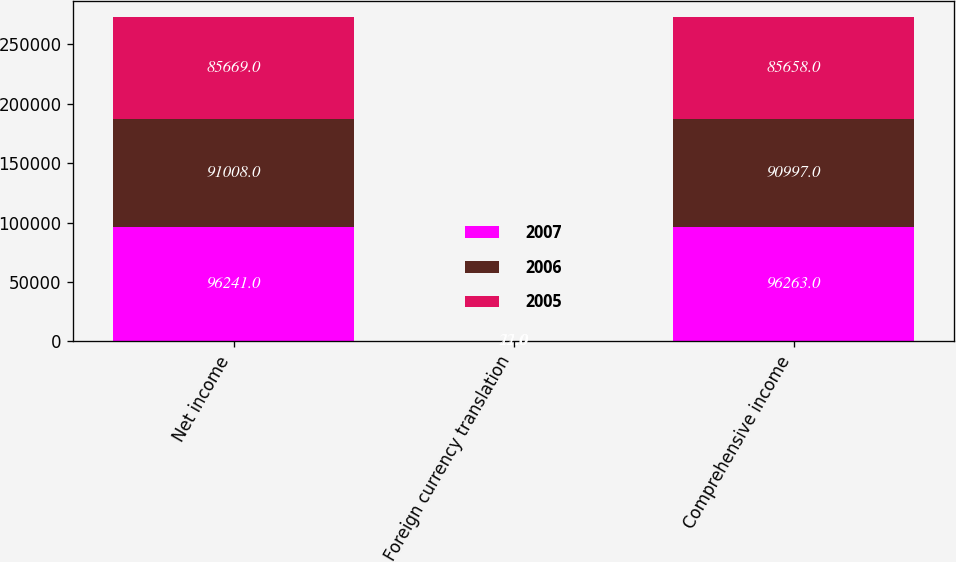Convert chart to OTSL. <chart><loc_0><loc_0><loc_500><loc_500><stacked_bar_chart><ecel><fcel>Net income<fcel>Foreign currency translation<fcel>Comprehensive income<nl><fcel>2007<fcel>96241<fcel>22<fcel>96263<nl><fcel>2006<fcel>91008<fcel>11<fcel>90997<nl><fcel>2005<fcel>85669<fcel>11<fcel>85658<nl></chart> 